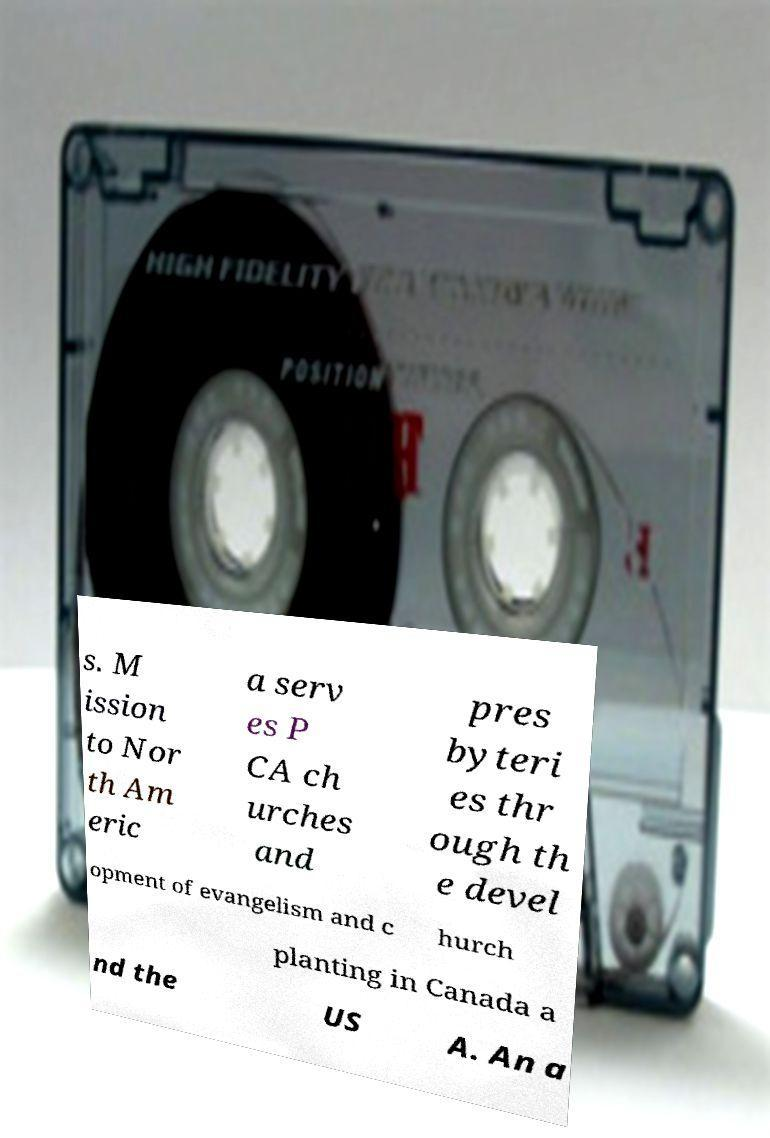Could you extract and type out the text from this image? s. M ission to Nor th Am eric a serv es P CA ch urches and pres byteri es thr ough th e devel opment of evangelism and c hurch planting in Canada a nd the US A. An a 